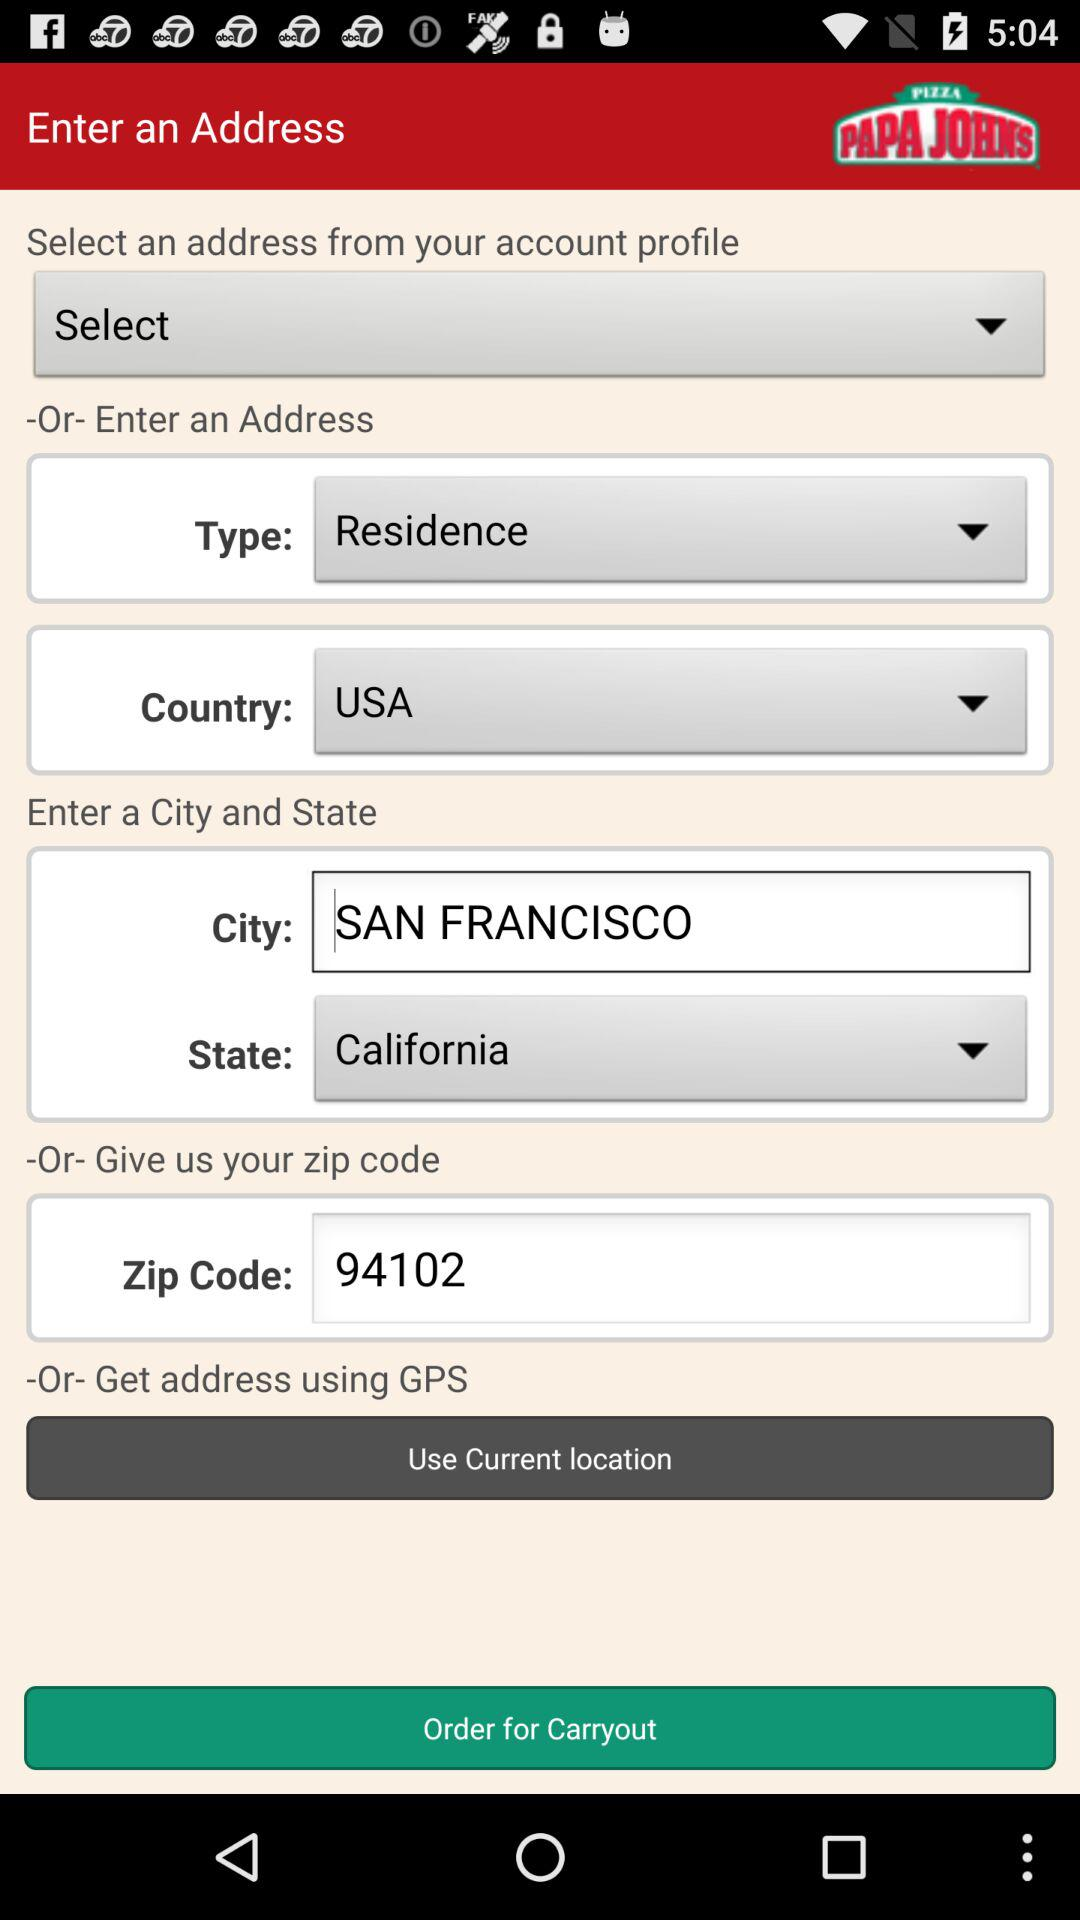Which is the selected country? The selected country is the USA. 